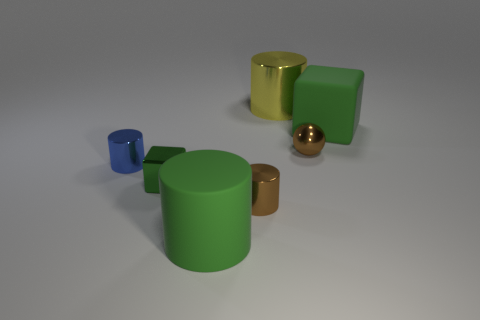How many other objects are the same material as the blue cylinder? Including the blue cylinder, there are a total of 5 objects that appear to be made of the same matte, non-reflective material. These objects are the blue cylinder, two green cubes, and two copper-colored cylinders, one larger and one smaller. 